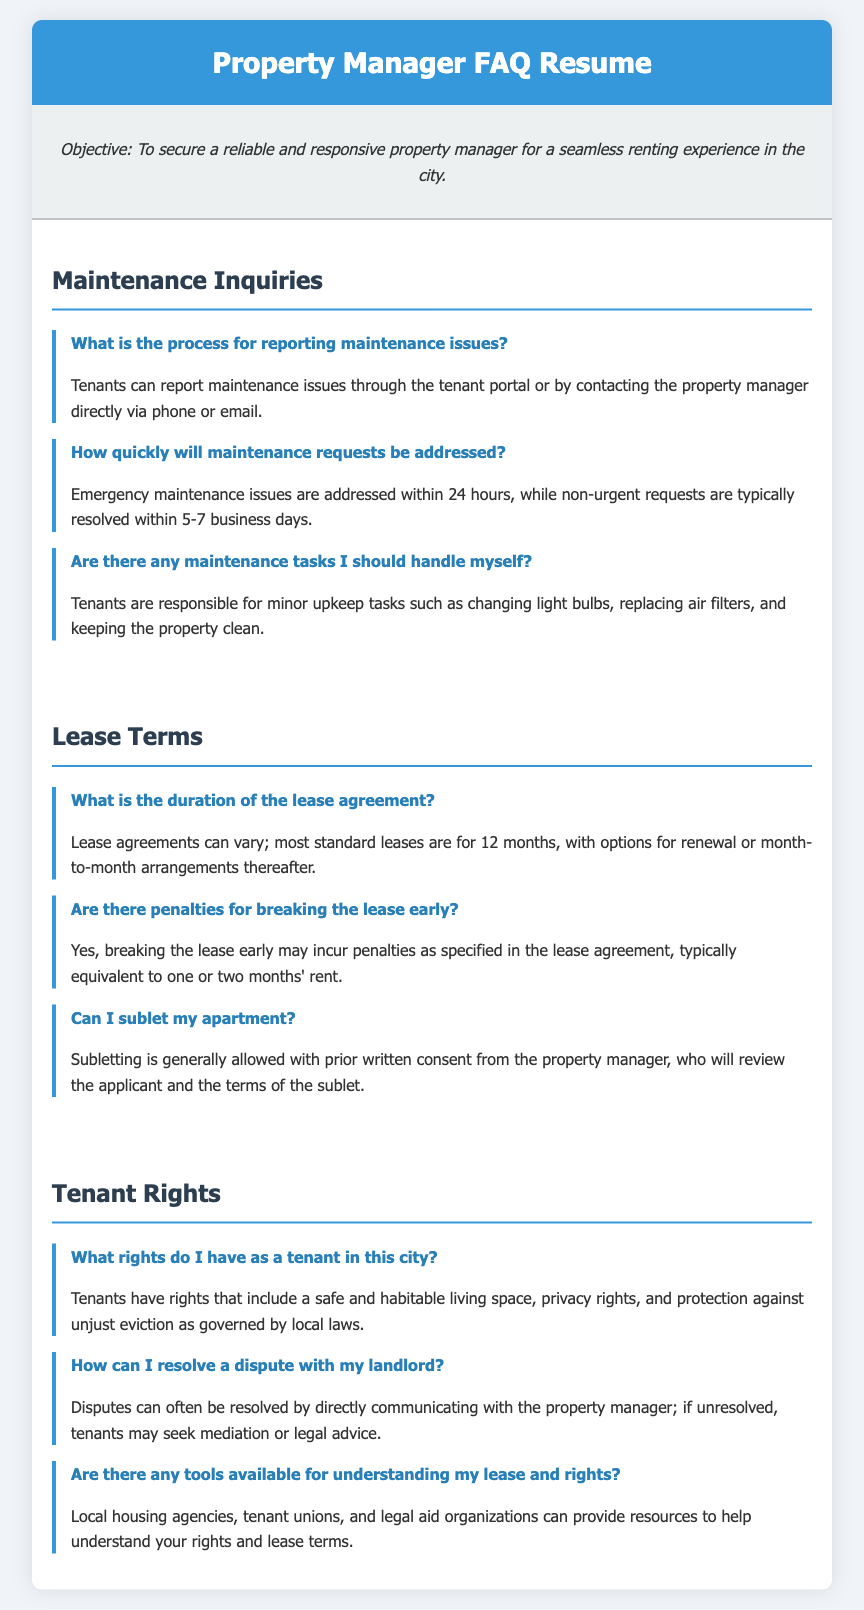What is the maximum time for emergency maintenance issues? The document states that emergency maintenance issues are addressed within 24 hours.
Answer: 24 hours What is the typical duration of standard lease agreements? According to the document, most standard leases are for 12 months.
Answer: 12 months What should tenants do for minor upkeep tasks? The document mentions that tenants are responsible for tasks such as changing light bulbs and replacing air filters.
Answer: Change light bulbs, replace air filters What are the penalties for breaking the lease early? The document specifies that breaking the lease early may incur penalties typically equivalent to one or two months' rent.
Answer: One or two months' rent What rights do tenants have regarding living conditions? The document indicates that tenants have the right to a safe and habitable living space.
Answer: Safe and habitable living space Can I sublet my apartment without consent? The document states that subletting is generally allowed with prior written consent from the property manager.
Answer: No, consent is required How long are non-urgent maintenance requests typically resolved? The document states non-urgent requests are typically resolved within 5-7 business days.
Answer: 5-7 business days What should I do if I have a dispute with my landlord? The document suggests communicating directly with the property manager for dispute resolution.
Answer: Communicate with property manager 